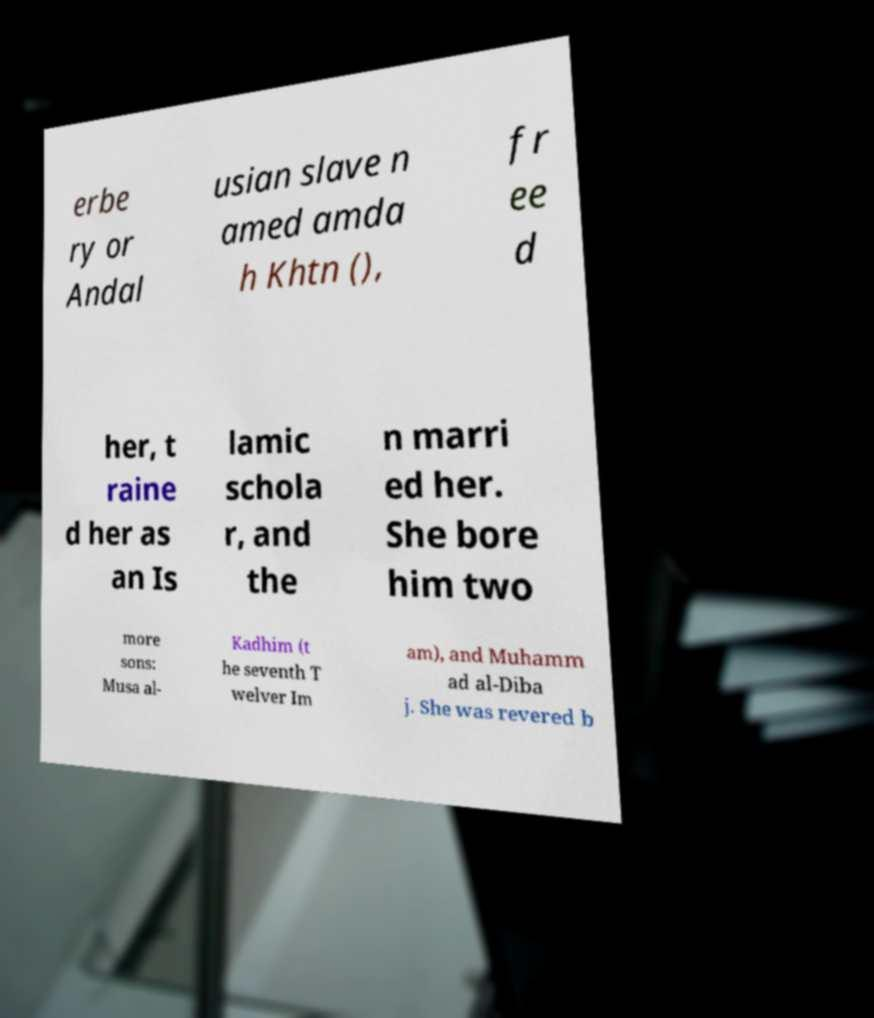I need the written content from this picture converted into text. Can you do that? erbe ry or Andal usian slave n amed amda h Khtn (), fr ee d her, t raine d her as an Is lamic schola r, and the n marri ed her. She bore him two more sons: Musa al- Kadhim (t he seventh T welver Im am), and Muhamm ad al-Diba j. She was revered b 